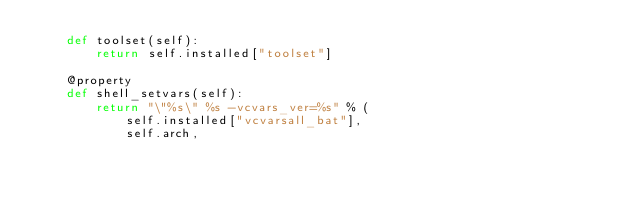<code> <loc_0><loc_0><loc_500><loc_500><_Python_>    def toolset(self):
        return self.installed["toolset"]

    @property
    def shell_setvars(self):
        return "\"%s\" %s -vcvars_ver=%s" % (
            self.installed["vcvarsall_bat"],
            self.arch,</code> 